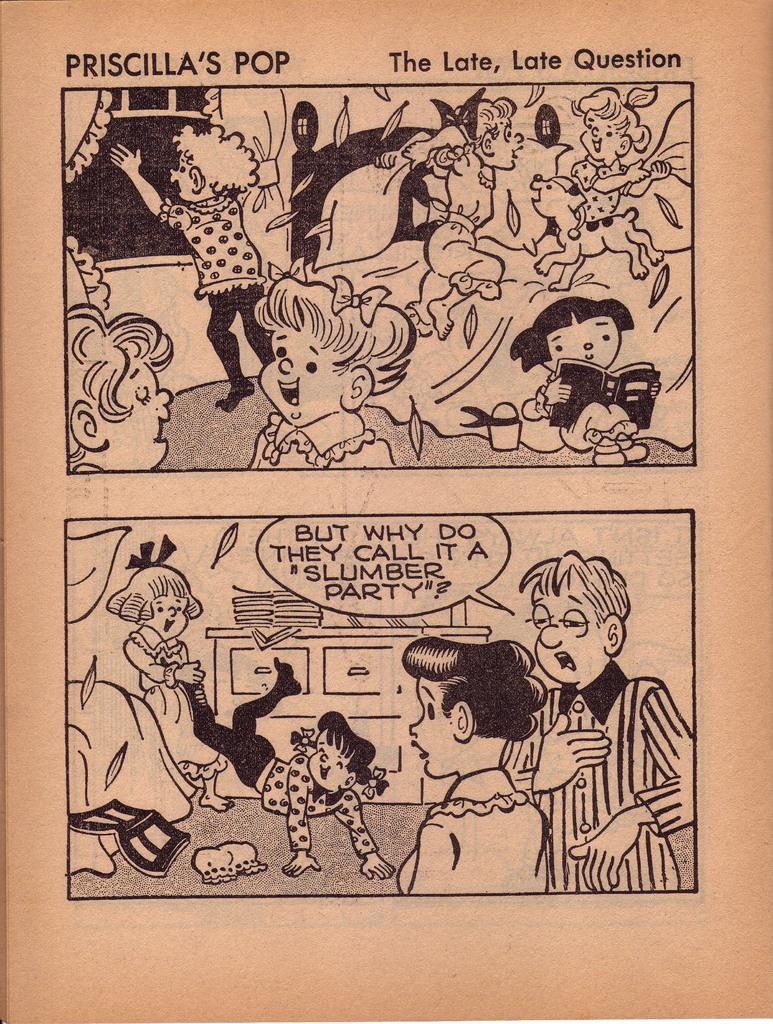<image>
Give a short and clear explanation of the subsequent image. Comic book about Priscilla's Pop and The late late  question. 